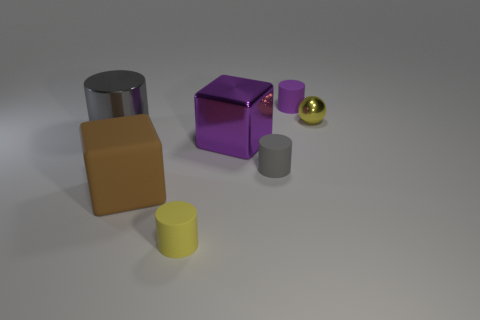There is a gray cylinder that is right of the big purple metal object; is it the same size as the block on the left side of the small yellow matte cylinder?
Make the answer very short. No. What material is the small object that is both behind the purple cube and left of the small yellow sphere?
Keep it short and to the point. Rubber. There is a thing that is the same color as the small metal sphere; what size is it?
Keep it short and to the point. Small. What number of other things are there of the same size as the metal ball?
Provide a short and direct response. 3. There is a small cylinder that is behind the tiny yellow shiny thing; what material is it?
Ensure brevity in your answer.  Rubber. Is the shape of the brown rubber object the same as the small gray matte thing?
Keep it short and to the point. No. What number of other things are the same shape as the large purple thing?
Provide a succinct answer. 1. There is a small object that is to the right of the small purple cylinder; what is its color?
Provide a short and direct response. Yellow. Is the size of the yellow metal sphere the same as the metal block?
Your answer should be compact. No. What material is the gray cylinder in front of the big shiny thing that is behind the purple metallic object?
Keep it short and to the point. Rubber. 